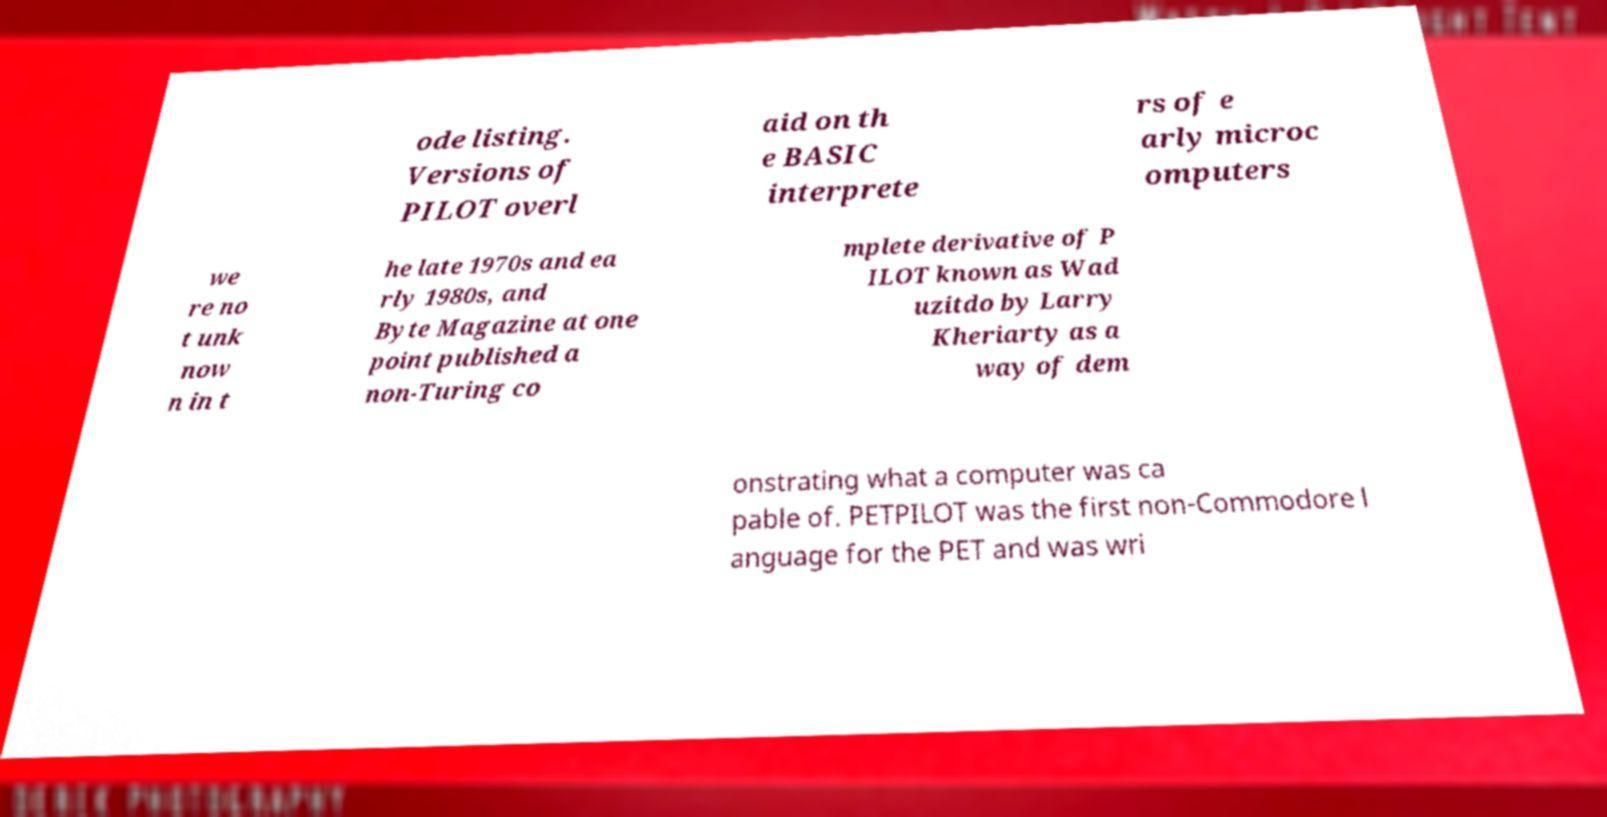What messages or text are displayed in this image? I need them in a readable, typed format. ode listing. Versions of PILOT overl aid on th e BASIC interprete rs of e arly microc omputers we re no t unk now n in t he late 1970s and ea rly 1980s, and Byte Magazine at one point published a non-Turing co mplete derivative of P ILOT known as Wad uzitdo by Larry Kheriarty as a way of dem onstrating what a computer was ca pable of. PETPILOT was the first non-Commodore l anguage for the PET and was wri 